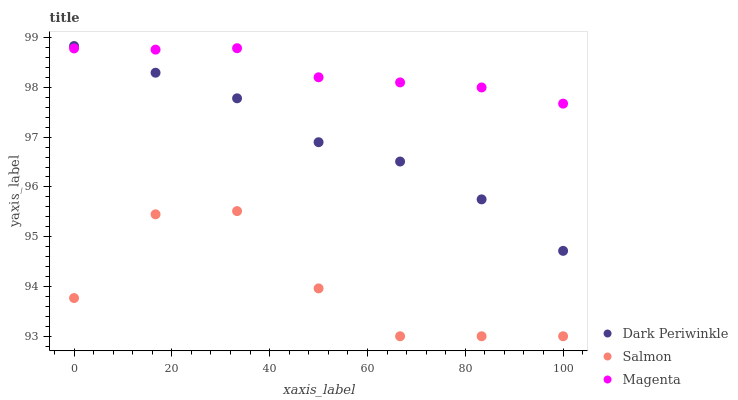Does Salmon have the minimum area under the curve?
Answer yes or no. Yes. Does Magenta have the maximum area under the curve?
Answer yes or no. Yes. Does Dark Periwinkle have the minimum area under the curve?
Answer yes or no. No. Does Dark Periwinkle have the maximum area under the curve?
Answer yes or no. No. Is Magenta the smoothest?
Answer yes or no. Yes. Is Salmon the roughest?
Answer yes or no. Yes. Is Dark Periwinkle the smoothest?
Answer yes or no. No. Is Dark Periwinkle the roughest?
Answer yes or no. No. Does Salmon have the lowest value?
Answer yes or no. Yes. Does Dark Periwinkle have the lowest value?
Answer yes or no. No. Does Dark Periwinkle have the highest value?
Answer yes or no. Yes. Does Salmon have the highest value?
Answer yes or no. No. Is Salmon less than Dark Periwinkle?
Answer yes or no. Yes. Is Dark Periwinkle greater than Salmon?
Answer yes or no. Yes. Does Dark Periwinkle intersect Magenta?
Answer yes or no. Yes. Is Dark Periwinkle less than Magenta?
Answer yes or no. No. Is Dark Periwinkle greater than Magenta?
Answer yes or no. No. Does Salmon intersect Dark Periwinkle?
Answer yes or no. No. 